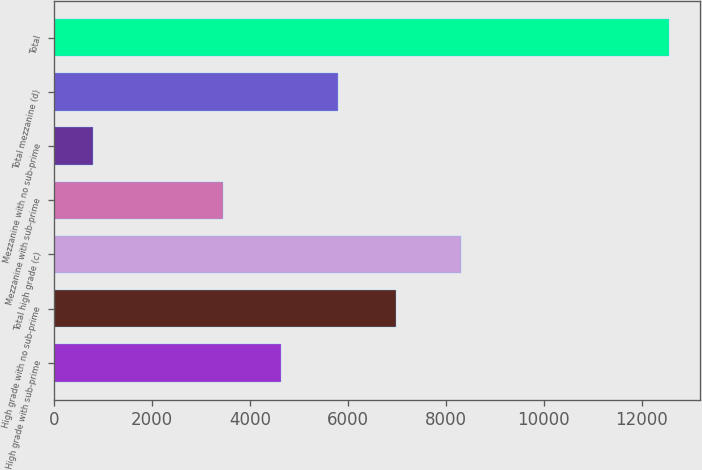Convert chart to OTSL. <chart><loc_0><loc_0><loc_500><loc_500><bar_chart><fcel>High grade with sub-prime<fcel>High grade with no sub-prime<fcel>Total high grade (c)<fcel>Mezzanine with sub-prime<fcel>Mezzanine with no sub-prime<fcel>Total mezzanine (d)<fcel>Total<nl><fcel>4628<fcel>6980<fcel>8308<fcel>3452<fcel>796<fcel>5804<fcel>12556<nl></chart> 